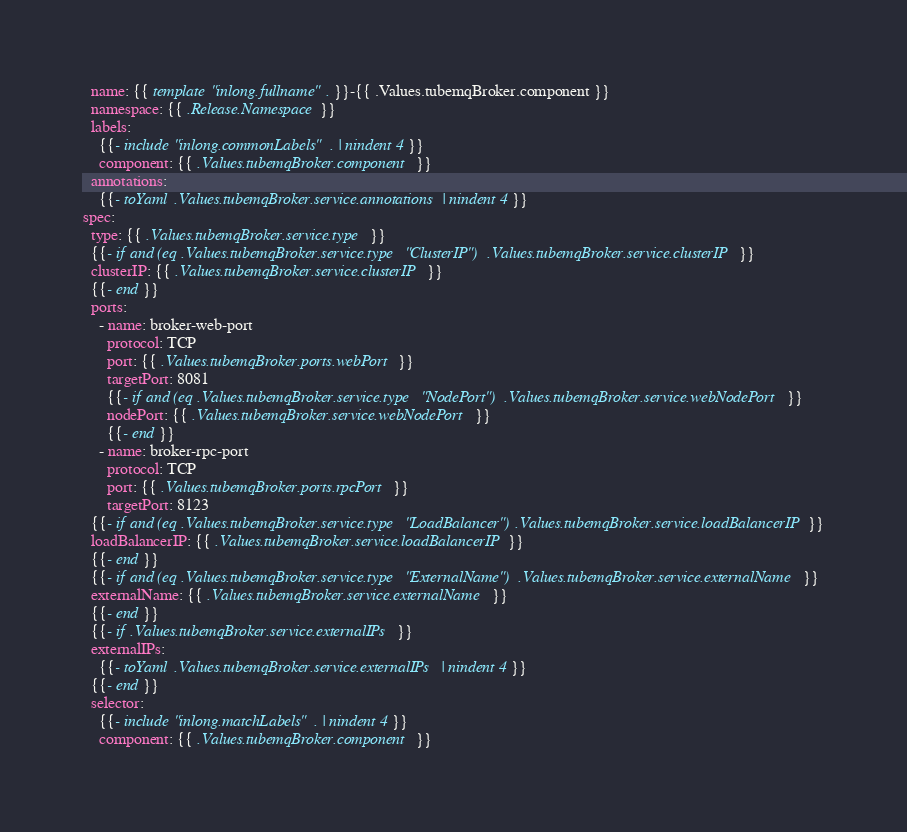<code> <loc_0><loc_0><loc_500><loc_500><_YAML_>  name: {{ template "inlong.fullname" . }}-{{ .Values.tubemqBroker.component }}
  namespace: {{ .Release.Namespace }}
  labels:
    {{- include "inlong.commonLabels" . | nindent 4 }}
    component: {{ .Values.tubemqBroker.component }}
  annotations:
    {{- toYaml .Values.tubemqBroker.service.annotations | nindent 4 }}
spec:
  type: {{ .Values.tubemqBroker.service.type }}
  {{- if and (eq .Values.tubemqBroker.service.type "ClusterIP") .Values.tubemqBroker.service.clusterIP }}
  clusterIP: {{ .Values.tubemqBroker.service.clusterIP }}
  {{- end }}
  ports:
    - name: broker-web-port
      protocol: TCP
      port: {{ .Values.tubemqBroker.ports.webPort }}
      targetPort: 8081
      {{- if and (eq .Values.tubemqBroker.service.type "NodePort") .Values.tubemqBroker.service.webNodePort }}
      nodePort: {{ .Values.tubemqBroker.service.webNodePort }}
      {{- end }}
    - name: broker-rpc-port
      protocol: TCP
      port: {{ .Values.tubemqBroker.ports.rpcPort }}
      targetPort: 8123
  {{- if and (eq .Values.tubemqBroker.service.type "LoadBalancer") .Values.tubemqBroker.service.loadBalancerIP }}
  loadBalancerIP: {{ .Values.tubemqBroker.service.loadBalancerIP }}
  {{- end }}
  {{- if and (eq .Values.tubemqBroker.service.type "ExternalName") .Values.tubemqBroker.service.externalName }}
  externalName: {{ .Values.tubemqBroker.service.externalName }}
  {{- end }}
  {{- if .Values.tubemqBroker.service.externalIPs }}
  externalIPs:
    {{- toYaml .Values.tubemqBroker.service.externalIPs | nindent 4 }}
  {{- end }}
  selector:
    {{- include "inlong.matchLabels" . | nindent 4 }}
    component: {{ .Values.tubemqBroker.component }}
</code> 